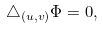Convert formula to latex. <formula><loc_0><loc_0><loc_500><loc_500>\triangle _ { ( u , v ) } \Phi = 0 ,</formula> 